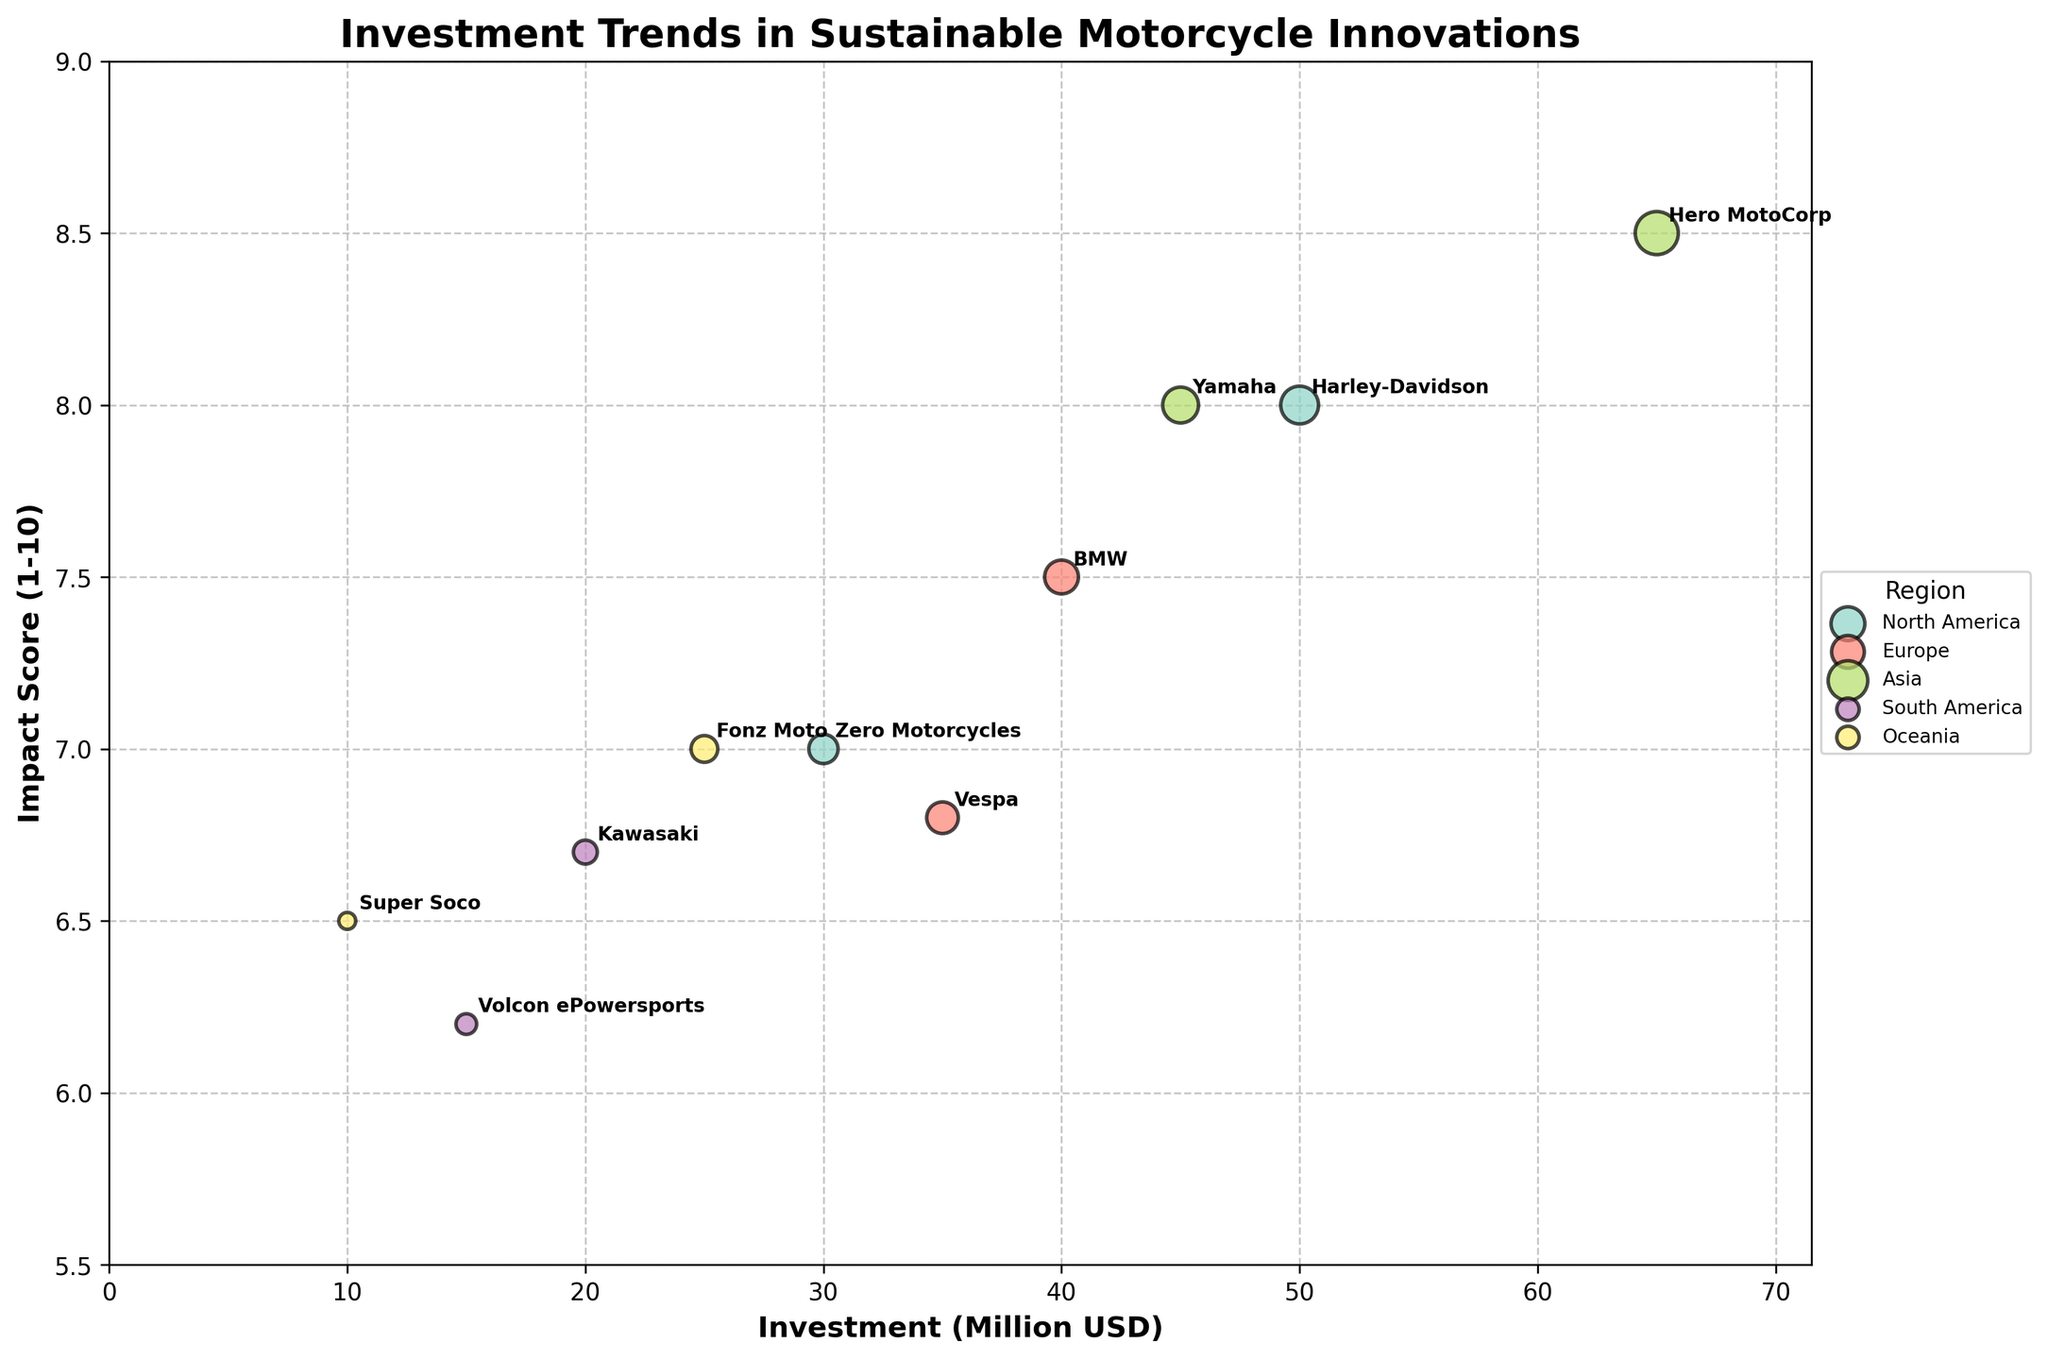How many regions are shown in the bubble chart? The chart contains a legend that lists the regions. By counting the number of unique colors and associated region labels, you can see that there are five regions.
Answer: Five What is the title of the bubble chart? The title is displayed at the top of the chart in bold text. It reads "Investment Trends in Sustainable Motorcycle Innovations."
Answer: Investment Trends in Sustainable Motorcycle Innovations Which company has the highest impact score? Look for the bubble with the highest position on the y-axis, which represents the impact score. Hero MotoCorp from Asia has the highest impact score with a value of 8.5.
Answer: Hero MotoCorp Which region has the smallest investment, and which company represents it? Find the smallest bubble on the x-axis representing investment. The smallest investment is from Oceania with Super Soco, having an investment of 10 million USD.
Answer: Oceania, Super Soco What is the total investment amount in Asia? Sum the investment values for the companies in the Asia region: Hero MotoCorp (65 million USD) and Yamaha (45 million USD). The total investment is 65 + 45 = 110 million USD.
Answer: 110 million USD Which region has the highest average impact score? Calculate the average impact score for each region. North America: (8+7)/2 = 7.5, Europe: (7.5+6.8)/2 = 7.15, Asia: (8.5+8)/2 = 8.25, South America: (6.7+6.2)/2 = 6.45, Oceania: (7+6.5)/2 = 6.75. Asia has the highest average impact score of 8.25.
Answer: Asia Compare the investments of Harley-Davidson and Zero Motorcycles. Which company received more investment and by how much? Locate the investment amounts for Harley-Davidson (50 million USD) and Zero Motorcycles (30 million USD). Subtract the smaller value from the larger one to find the difference: 50 - 30 = 20 million USD. Harley-Davidson received more by 20 million USD.
Answer: Harley-Davidson, 20 million USD Which region has the highest sum of impact scores? Sum the impact scores for each region. North America: 8+7=15, Europe: 7.5+6.8=14.3, Asia: 8.5+8=16.5, South America: 6.7+6.2=12.9, Oceania: 7+6.5=13.5. Asia has the highest sum of impact scores with 16.5.
Answer: Asia What is the difference in impact score between Vespa and Kawasaki? Find the impact scores for Vespa (6.8) and Kawasaki (6.7). Calculate the difference: 6.8 - 6.7 = 0.1. The difference is 0.1.
Answer: 0.1 Between BMW and Hero MotoCorp, which company is associated with a larger bubble? The size of the bubble is proportional to the investment amount. Compare the investment values for BMW (40 million USD) and Hero MotoCorp (65 million USD). Hero MotoCorp has a larger bubble due to a higher investment.
Answer: Hero MotoCorp 